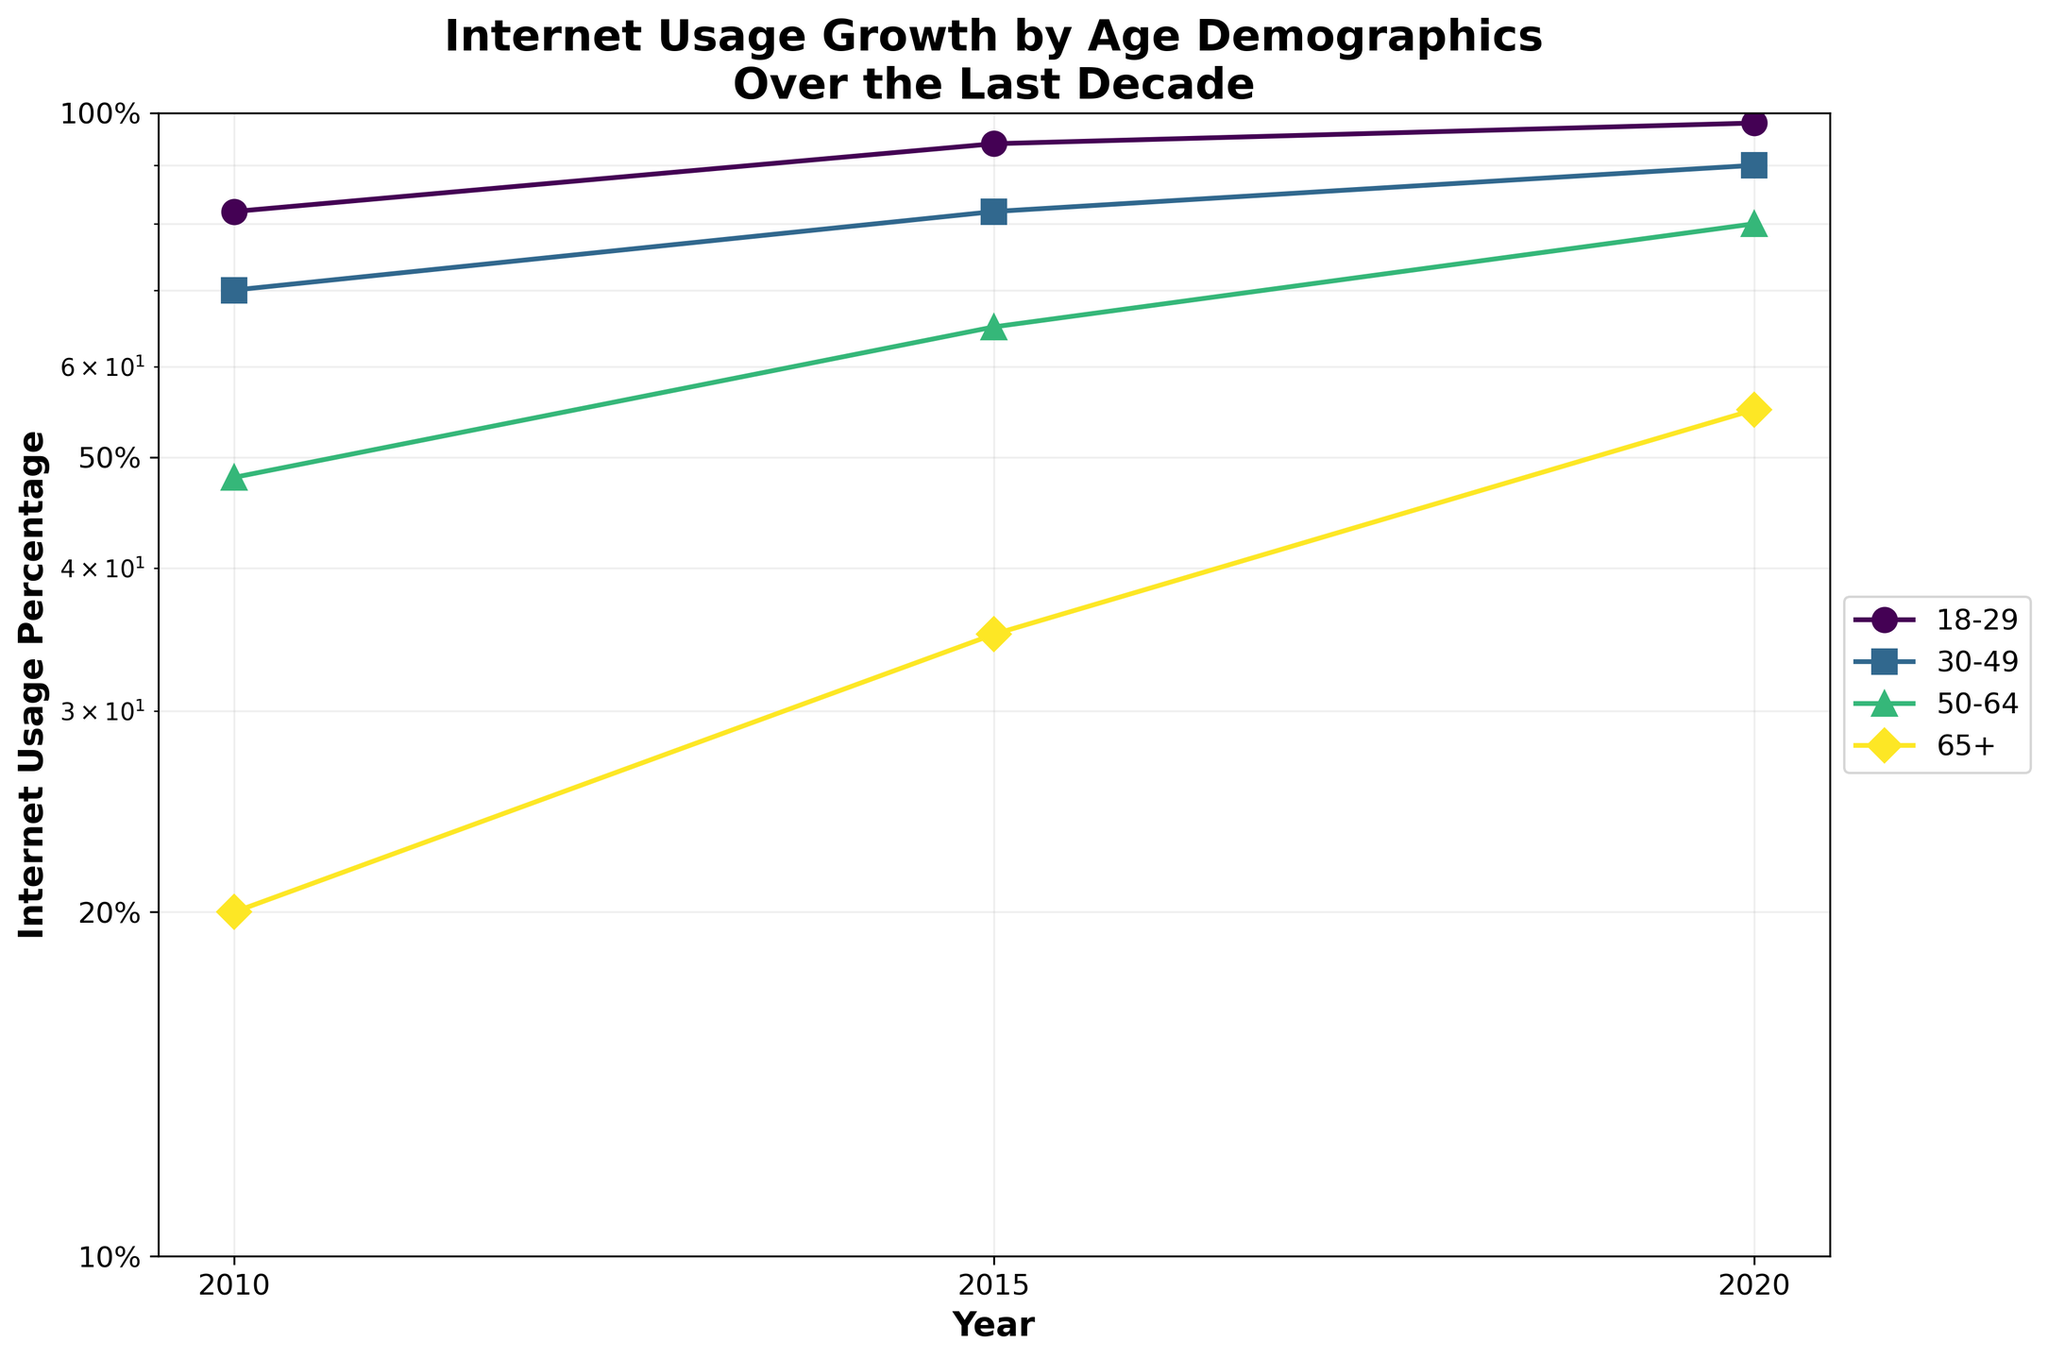what is the title of the figure? The title is typically placed at the top middle of the figure. In this case, it reads 'Internet Usage Growth by Age Demographics Over the Last Decade'.
Answer: 'Internet Usage Growth by Age Demographics Over the Last Decade' What are the y-axis labels? The labels for the y-axis typically specify the units or measurement type. Here, they are '10%', '20%', '50%', and '100%', depicting the percentage of Internet usage visually represented on a logarithmic scale.
Answer: '10%', '20%', '50%', '100%' How does Internet usage in the 18-29 age group change from 2010 to 2020? By visually following the line marker 'o' for the 18-29 age group from 2010 to 2020, we observe that the internet usage increases from 82% to 98%.
Answer: 82% to 98% Which age group showed the largest percentage increase in Internet usage over the decade? We need to calculate the percentage increase for each age group and compare them. The increases are:
- 18-29: 98% - 82% = 16%
- 30-49: 90% - 70% = 20%
- 50-64: 80% - 48% = 32%
- 65+: 55% - 20% = 35%
The 65+ age group shows the largest increase of 35%.
Answer: 65+ What is the average Internet usage percentage of the 30-49 age group over the decade? The Internet usage percentages for the 30-49 age group are 70% (2010), 82% (2015), and 90% (2020). The average is calculated as follows: (70 + 82 + 90) / 3 = 242 / 3 ≈ 80.67%.
Answer: 80.67% Which age demographic had the lowest Internet usage in 2015? By identifying the lowest point in the year 2015 along the x-axis, we see that the 65+ age group has the lowest Internet usage at 35%.
Answer: 65+ What's the difference in Internet usage percentage between the 50-64 and 65+ age groups in 2020? The Internet usage in 2020 is 80% for the 50-64 age group and 55% for the 65+ age group. The difference is calculated as 80% - 55% = 25%.
Answer: 25% How has the Internet usage trend for the 50-64 age group shifted over the decade? Examining the 'D' marker for the 50-64 age group from 2010 to 2020, we observe a consistent upward trend with the percentages increasing from 48% to 80%.
Answer: Increased from 48% to 80% Are there any age groups that achieved over 90% Internet usage by 2020? Looking at the markers for each age group in 2020, the 18-29 (98%) and 30-49 (90%) groups have achieved over 90% Internet usage.
Answer: 18-29 and 30-49 